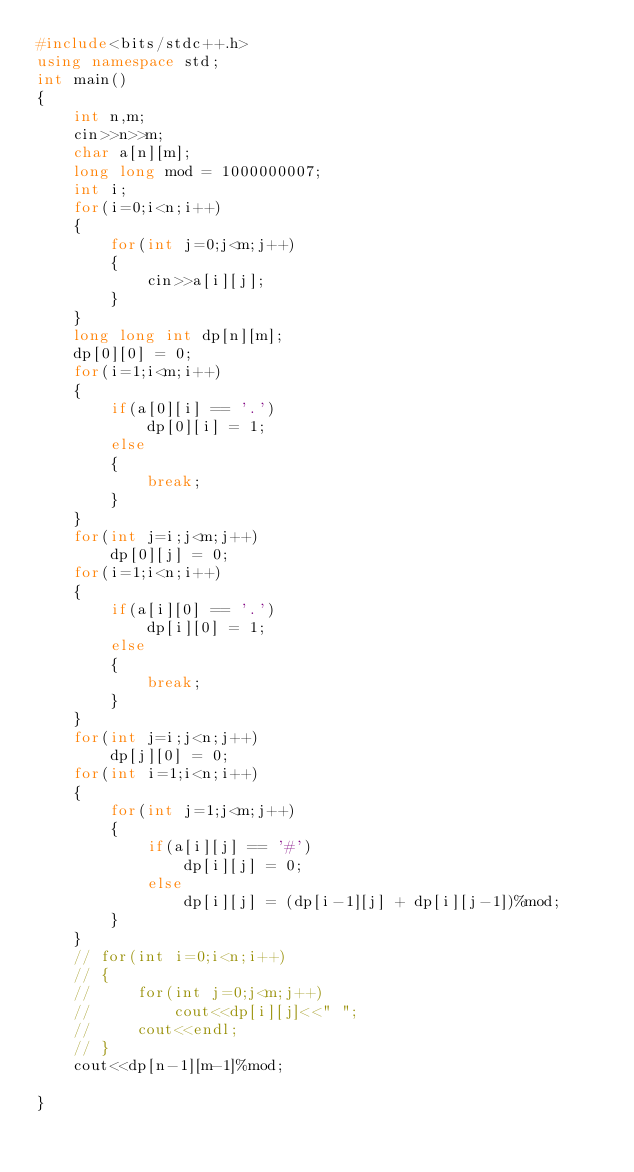Convert code to text. <code><loc_0><loc_0><loc_500><loc_500><_C++_>#include<bits/stdc++.h>
using namespace std;
int main()
{
    int n,m;
    cin>>n>>m;
    char a[n][m];
    long long mod = 1000000007;
    int i;
    for(i=0;i<n;i++)
    {
        for(int j=0;j<m;j++)
        {
            cin>>a[i][j];
        }
    }
    long long int dp[n][m];
    dp[0][0] = 0;
    for(i=1;i<m;i++)
    {
        if(a[0][i] == '.')
            dp[0][i] = 1;
        else
        {
            break;
        }
    }
    for(int j=i;j<m;j++)
        dp[0][j] = 0;
    for(i=1;i<n;i++)
    {
        if(a[i][0] == '.')
            dp[i][0] = 1;
        else
        {
            break;
        }
    }
    for(int j=i;j<n;j++)
        dp[j][0] = 0;
    for(int i=1;i<n;i++)
    {
        for(int j=1;j<m;j++)
        {
            if(a[i][j] == '#')
                dp[i][j] = 0;
            else
                dp[i][j] = (dp[i-1][j] + dp[i][j-1])%mod;
        }
    }
    // for(int i=0;i<n;i++)
    // {
    //     for(int j=0;j<m;j++)
    //         cout<<dp[i][j]<<" ";
    //     cout<<endl;    
    // }
    cout<<dp[n-1][m-1]%mod;
        
}</code> 